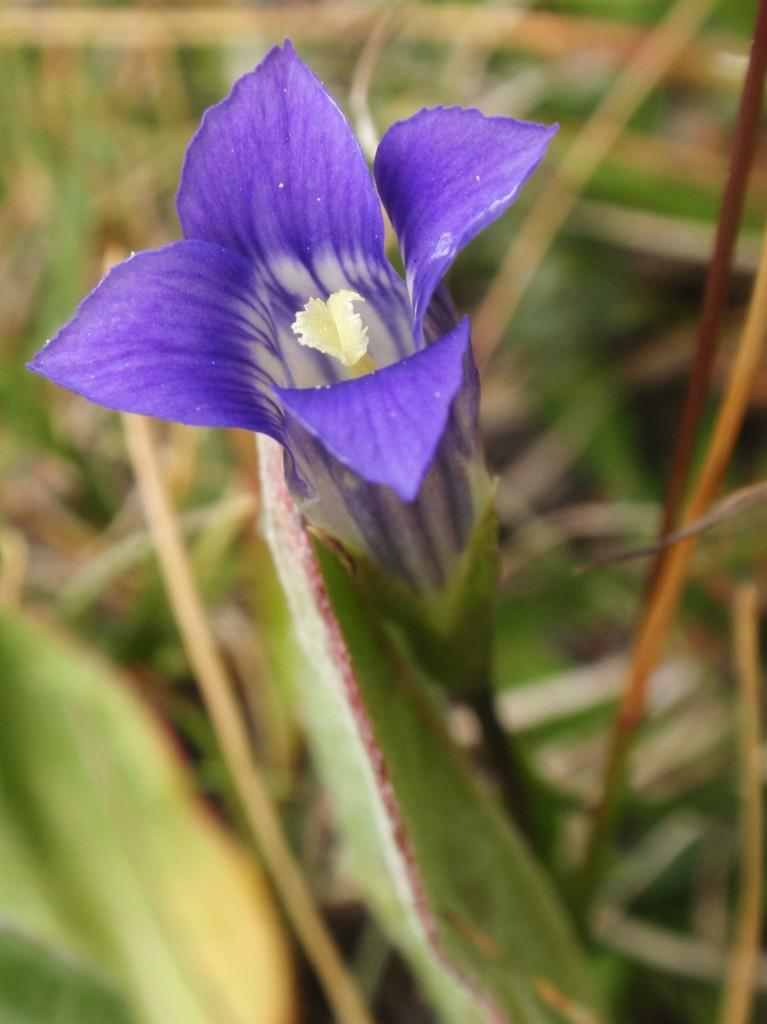What type of flower is in the image? There is a purple flower in the image. Can you describe the background of the image? The background of the image is blurred. What type of alarm can be heard going off in the image? There is no alarm present in the image, as it is a still photograph of a flower. 